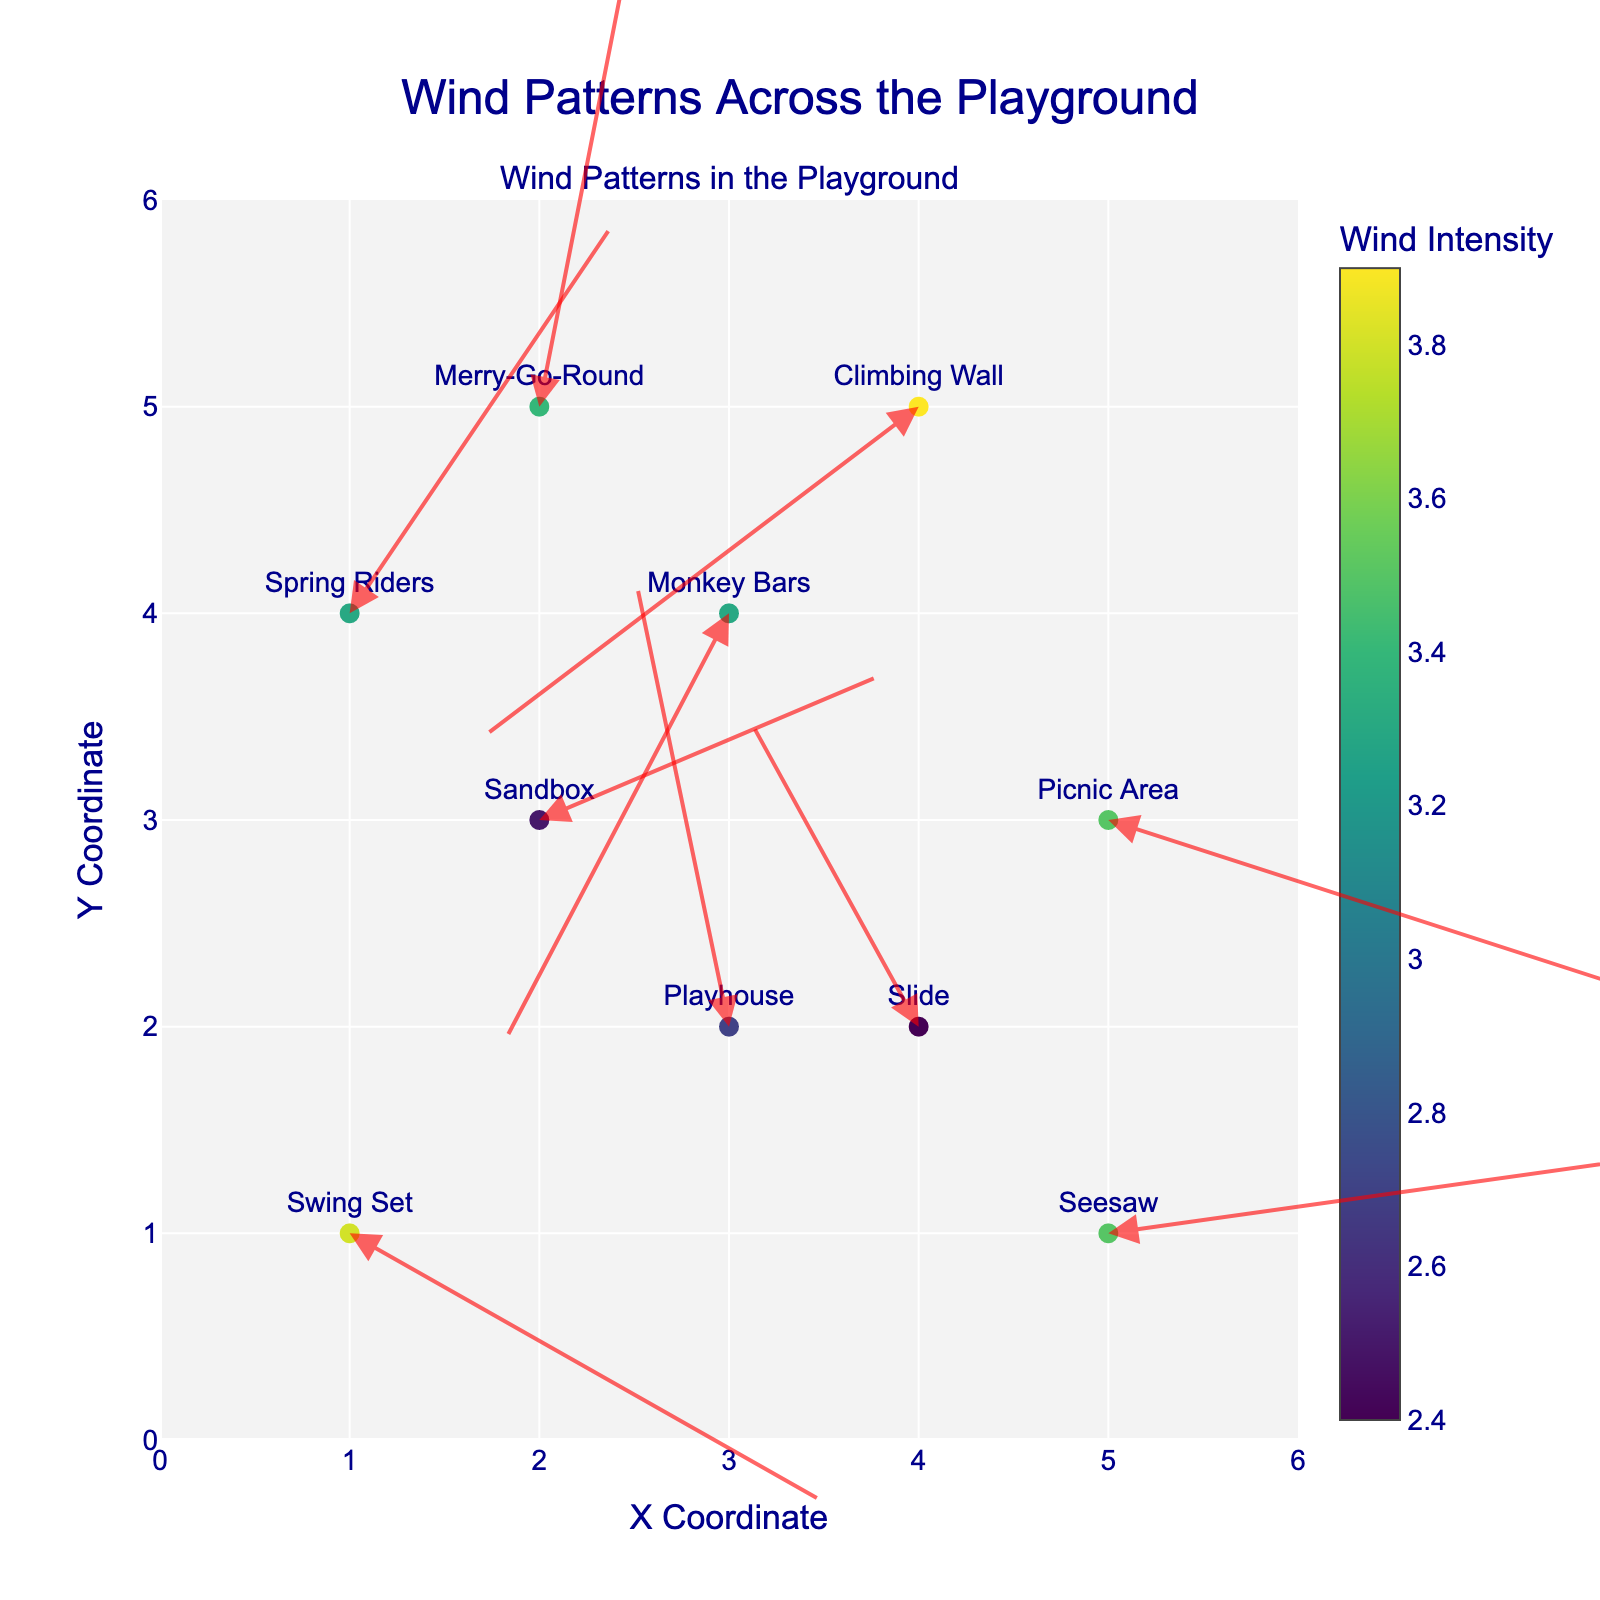What is the title of the plot? The title is displayed at the top center of the figure and reads "Wind Patterns Across the Playground".
Answer: Wind Patterns Across the Playground How many locations are shown in the plot? Count the number of data points or markers in the figure. Each point represents a specific location in the playground.
Answer: 10 Which location has the highest wind intensity? Wind intensity is represented by the color scale. The Picnic Area has the highest color intensity which translates to the highest wind intensity.
Answer: Picnic Area What are the X and Y coordinates of the Merry-Go-Round? Refer to the position of the Merry-Go-Round marker on the plot, it is located at (2,5).
Answer: (2,5) Which direction is the wind blowing at the Seesaw? Look at the arrow originating from the Seesaw point. The arrow is pointing to a new position along the coordinates (5+3.1, 1+0.4) = (8.1, 1.4), which shows the direction.
Answer: Right and slightly up Is there any location where the wind is blowing towards the left side of the plot? Analyze the vectors to see their direction. The Slide is moving towards the left as indicated by its negative U component.
Answer: Slide Compare the wind intensity between the Spring Riders and the Playhouse. Which one experiences stronger wind? Compare the color intensities of the markers. The Spring Riders have a higher combined value of U and V compared to the Playhouse as indicated by the color.
Answer: Spring Riders Which two locations have the most similar wind direction vectors? Observe the direction of the arrows. The Swing Set and Picnic Area have wind vectors pointing towards the right and slightly downward, showing similar directions.
Answer: Swing Set and Picnic Area What's the sum of the X-coordinates of all locations? Add all the X-coordinates provided: 1+2+4+3+5+2+4+1+5+3 = 30.
Answer: 30 Does any location have its wind vector pointing directly upward? Check if any vector is vertical and pointing upwards, which means it has zero U and positive V value. None of the vectors meet this criterion.
Answer: No 